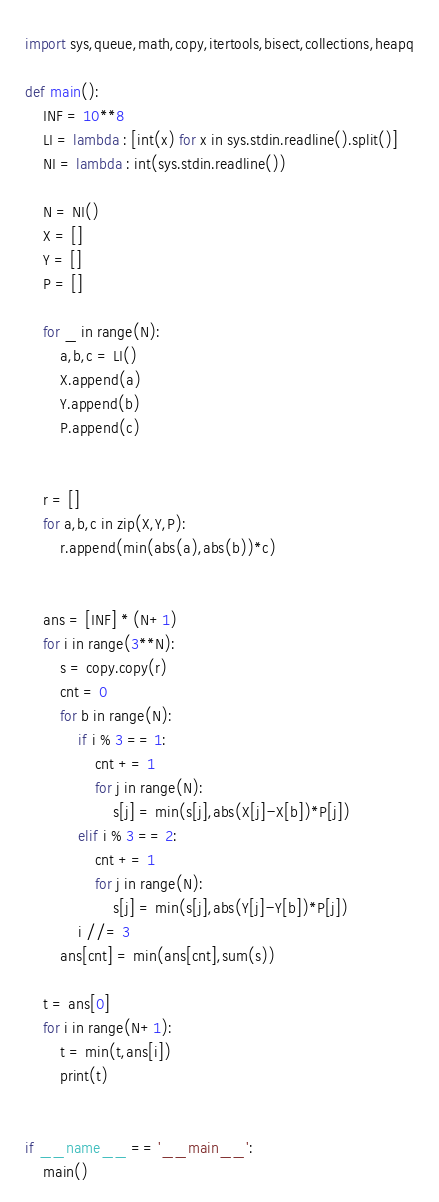<code> <loc_0><loc_0><loc_500><loc_500><_Python_>import sys,queue,math,copy,itertools,bisect,collections,heapq

def main():
    INF = 10**8
    LI = lambda : [int(x) for x in sys.stdin.readline().split()]
    NI = lambda : int(sys.stdin.readline())

    N = NI()
    X = []
    Y = []
    P = []

    for _ in range(N):
        a,b,c = LI()
        X.append(a)
        Y.append(b)
        P.append(c)


    r = []
    for a,b,c in zip(X,Y,P):
        r.append(min(abs(a),abs(b))*c)


    ans = [INF] * (N+1)
    for i in range(3**N):
        s = copy.copy(r)
        cnt = 0
        for b in range(N):
            if i % 3 == 1:
                cnt += 1
                for j in range(N):
                    s[j] = min(s[j],abs(X[j]-X[b])*P[j])
            elif i % 3 == 2:
                cnt += 1
                for j in range(N):
                    s[j] = min(s[j],abs(Y[j]-Y[b])*P[j])
            i //= 3
        ans[cnt] = min(ans[cnt],sum(s))

    t = ans[0]
    for i in range(N+1):
        t = min(t,ans[i])
        print(t)


if __name__ == '__main__':
    main()</code> 